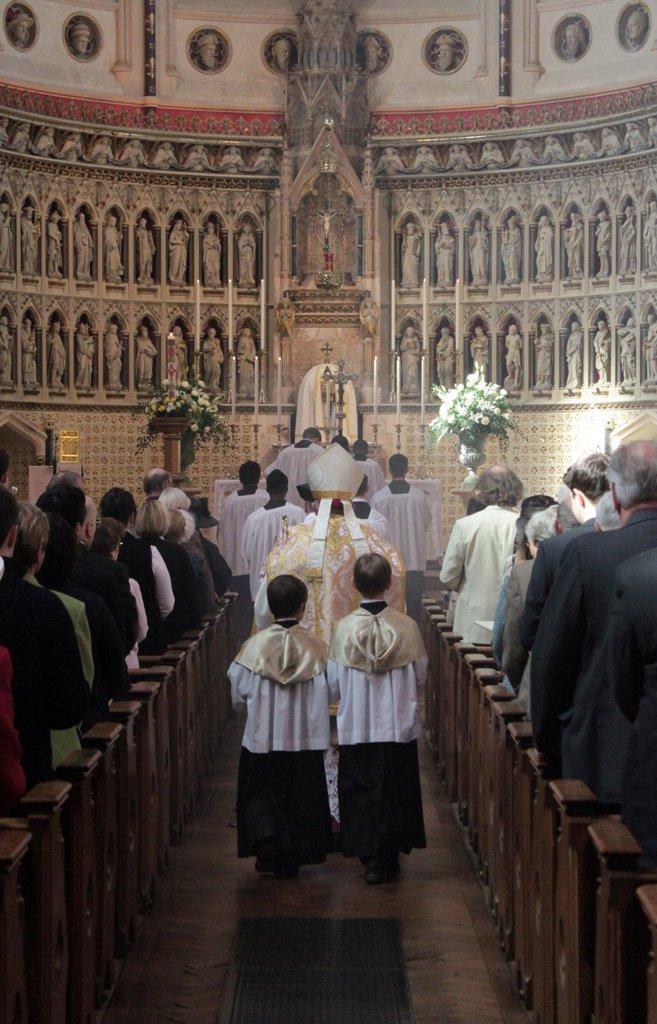Can you describe this image briefly? As we can see in the image there are chairs, few people here and there, bouquets and statues. 